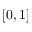<formula> <loc_0><loc_0><loc_500><loc_500>[ 0 , 1 ]</formula> 